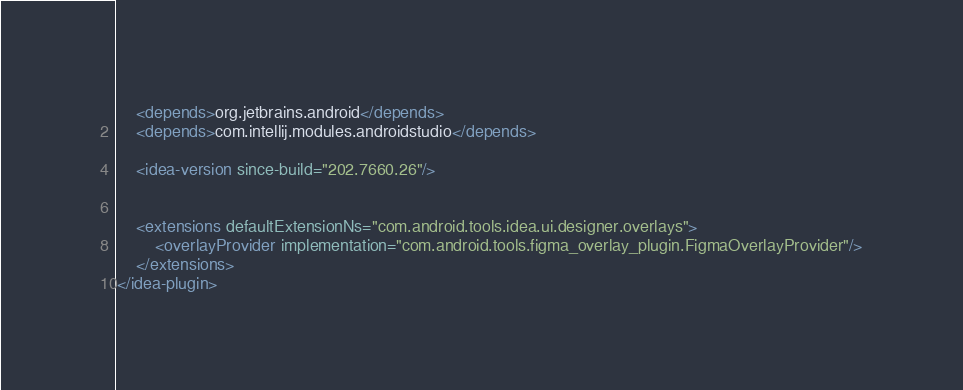<code> <loc_0><loc_0><loc_500><loc_500><_XML_>    <depends>org.jetbrains.android</depends>
    <depends>com.intellij.modules.androidstudio</depends>

    <idea-version since-build="202.7660.26"/>


    <extensions defaultExtensionNs="com.android.tools.idea.ui.designer.overlays">
        <overlayProvider implementation="com.android.tools.figma_overlay_plugin.FigmaOverlayProvider"/>
    </extensions>
</idea-plugin>
</code> 